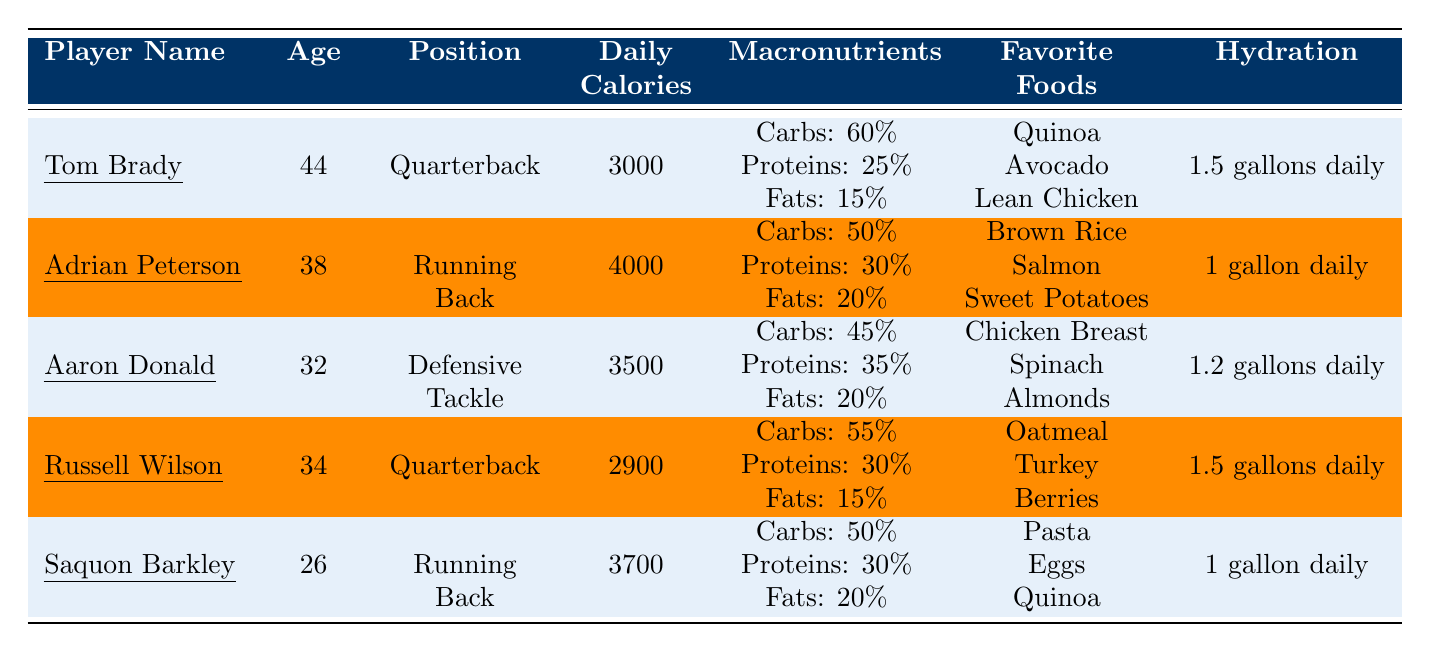What is the daily caloric intake of Tom Brady? The table specifically states that Tom Brady has a daily caloric intake of 3000 calories.
Answer: 3000 calories Which player is the youngest in the table? Among the ages listed, Saquon Barkley is 26 years old, which is younger than the others (44, 38, 32, and 34).
Answer: Saquon Barkley What percentage of protein does Adrian Peterson consume? According to the macronutrient distribution for Adrian Peterson, he consumes 30% protein.
Answer: 30% Which player drinks the most water daily? By comparing the hydration information, Tom Brady and Russell Wilson both consume 1.5 gallons of water daily, which is more than the others.
Answer: Tom Brady and Russell Wilson What is the average daily caloric intake of all players? To find the average, sum the daily caloric intakes (3000 + 4000 + 3500 + 2900 + 3700 = 20100) and divide by the number of players (5). This gives 20100 / 5 = 4020 calories as the average.
Answer: 4020 calories Do all players have the same hydration amount? Comparing the hydration amounts reveals they differ: Tom Brady and Russell Wilson drink 1.5 gallons, Adrian Peterson and Saquon Barkley drink 1 gallon, and Aaron Donald drinks 1.2 gallons. Thus, it's false that all players have the same hydration.
Answer: No What percentage of fats does Aaron Donald consume compared to Saquon Barkley? Aaron Donald consumes 20% fats, while Saquon Barkley also has a fat intake of 20%. Both players have the same percentage of fats.
Answer: They are the same (20%) Which player has the highest protein intake? By reviewing the protein percentages, Aaron Donald has the highest at 35%, compared to others (25%, 30%, and the same for Saquon Barkley).
Answer: Aaron Donald Are carbohydrates more than 50% for all players? Checking the carbohydrate percentages shows that Tom Brady, Russell Wilson, and Adrian Peterson have above 50%, while Aaron Donald has 45% and Saquon Barkley has 50%. Therefore, it is false that carbs are more than 50% for all.
Answer: No What is the combined age of Tom Brady and Russell Wilson? Adding their ages gives 44 (Tom Brady) + 34 (Russell Wilson) = 78.
Answer: 78 